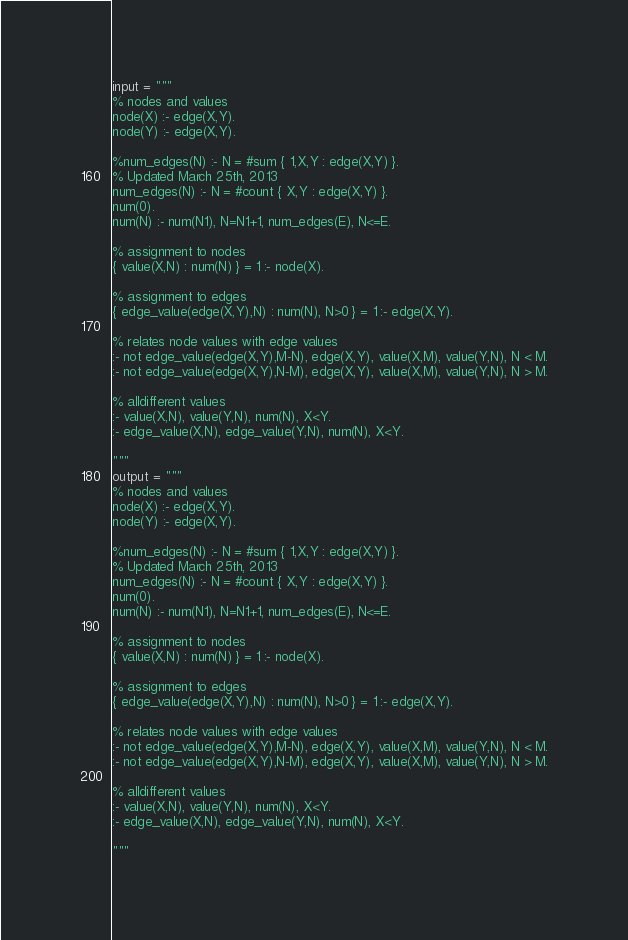Convert code to text. <code><loc_0><loc_0><loc_500><loc_500><_Python_>input = """
% nodes and values
node(X) :- edge(X,Y).
node(Y) :- edge(X,Y).

%num_edges(N) :- N = #sum { 1,X,Y : edge(X,Y) }.
% Updated March 25th, 2013
num_edges(N) :- N = #count { X,Y : edge(X,Y) }.
num(0).
num(N) :- num(N1), N=N1+1, num_edges(E), N<=E.

% assignment to nodes
{ value(X,N) : num(N) } = 1 :- node(X).

% assignment to edges
{ edge_value(edge(X,Y),N) : num(N), N>0 } = 1 :- edge(X,Y).

% relates node values with edge values
:- not edge_value(edge(X,Y),M-N), edge(X,Y), value(X,M), value(Y,N), N < M.
:- not edge_value(edge(X,Y),N-M), edge(X,Y), value(X,M), value(Y,N), N > M.

% alldifferent values
:- value(X,N), value(Y,N), num(N), X<Y.
:- edge_value(X,N), edge_value(Y,N), num(N), X<Y.

"""
output = """
% nodes and values
node(X) :- edge(X,Y).
node(Y) :- edge(X,Y).

%num_edges(N) :- N = #sum { 1,X,Y : edge(X,Y) }.
% Updated March 25th, 2013
num_edges(N) :- N = #count { X,Y : edge(X,Y) }.
num(0).
num(N) :- num(N1), N=N1+1, num_edges(E), N<=E.

% assignment to nodes
{ value(X,N) : num(N) } = 1 :- node(X).

% assignment to edges
{ edge_value(edge(X,Y),N) : num(N), N>0 } = 1 :- edge(X,Y).

% relates node values with edge values
:- not edge_value(edge(X,Y),M-N), edge(X,Y), value(X,M), value(Y,N), N < M.
:- not edge_value(edge(X,Y),N-M), edge(X,Y), value(X,M), value(Y,N), N > M.

% alldifferent values
:- value(X,N), value(Y,N), num(N), X<Y.
:- edge_value(X,N), edge_value(Y,N), num(N), X<Y.

"""
</code> 